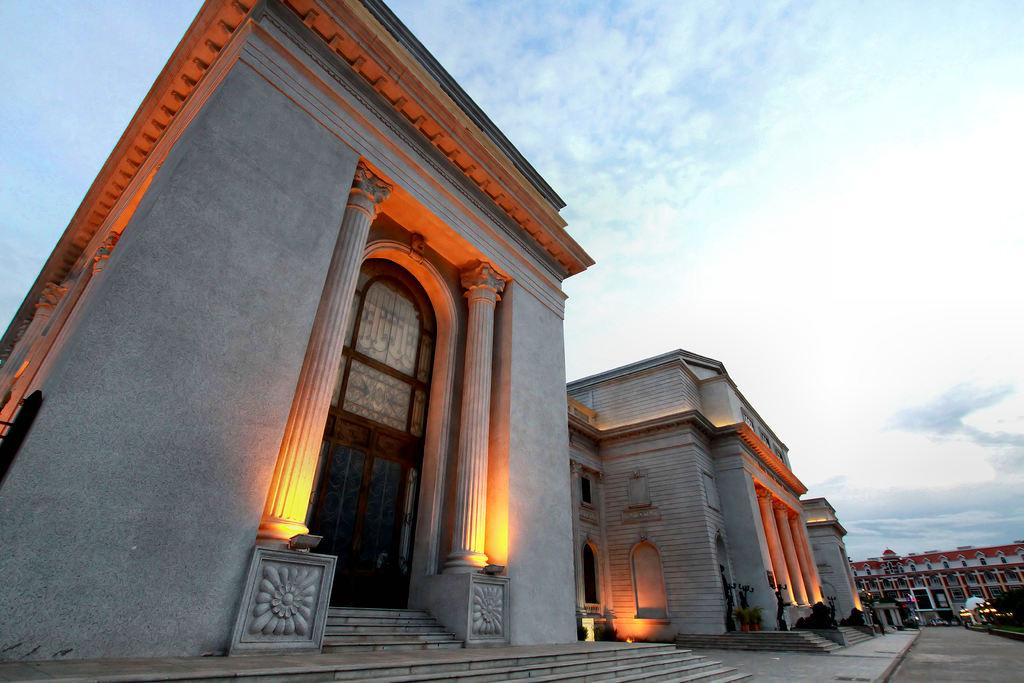What type of structures can be seen in the image? There are buildings in the image. What type of lighting is present in the image? Electric lights are present in the image. Are there any architectural features visible in the image? Yes, there are stairs in the image. What type of vegetation can be seen in the image? Trees are visible in the image. What is visible in the background of the image? The sky is visible in the background of the image. What can be observed in the sky? Clouds are present in the sky. What type of food is being served for lunch in the image? There is no food or mention of lunch in the image; it primarily features buildings, electric lights, stairs, trees, and the sky. 